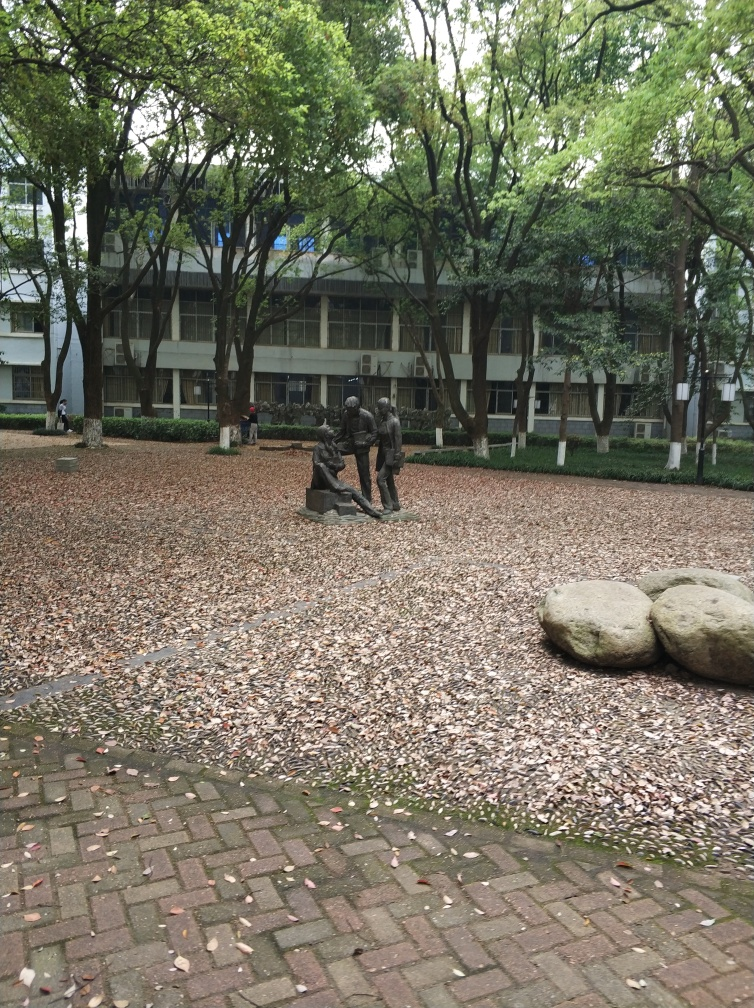How might the weather be in this image, judging by the environment? The overcast sky and the presence of fallen leaves on the ground suggest that the weather could be cool, possibly in the late autumn months. The absence of people suggests it might be a tranquil time of day or a brisk day where people prefer indoor warmth. 